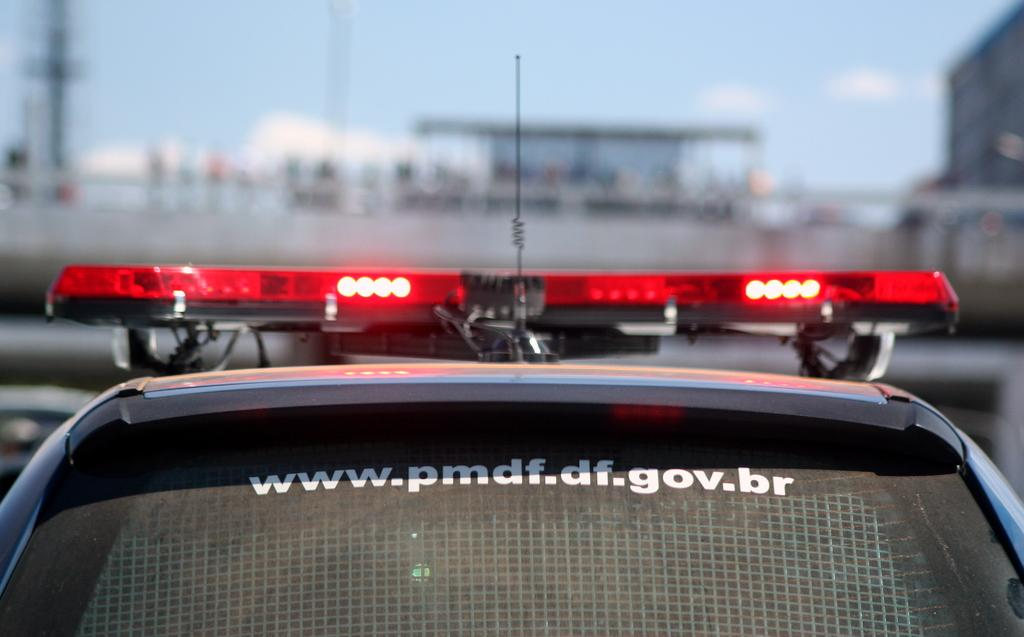What is the main subject of the picture? The main subject of the picture is a car. Can you describe any specific features of the car? Yes, there is text on the back windshield of the car. What can be seen in the background of the image? The background of the image is blurred, and the sky is visible. How does the journey of the dolls affect the digestion of the car in the image? There are no dolls present in the image, and cars do not have digestive systems, so this question cannot be answered based on the information provided. 